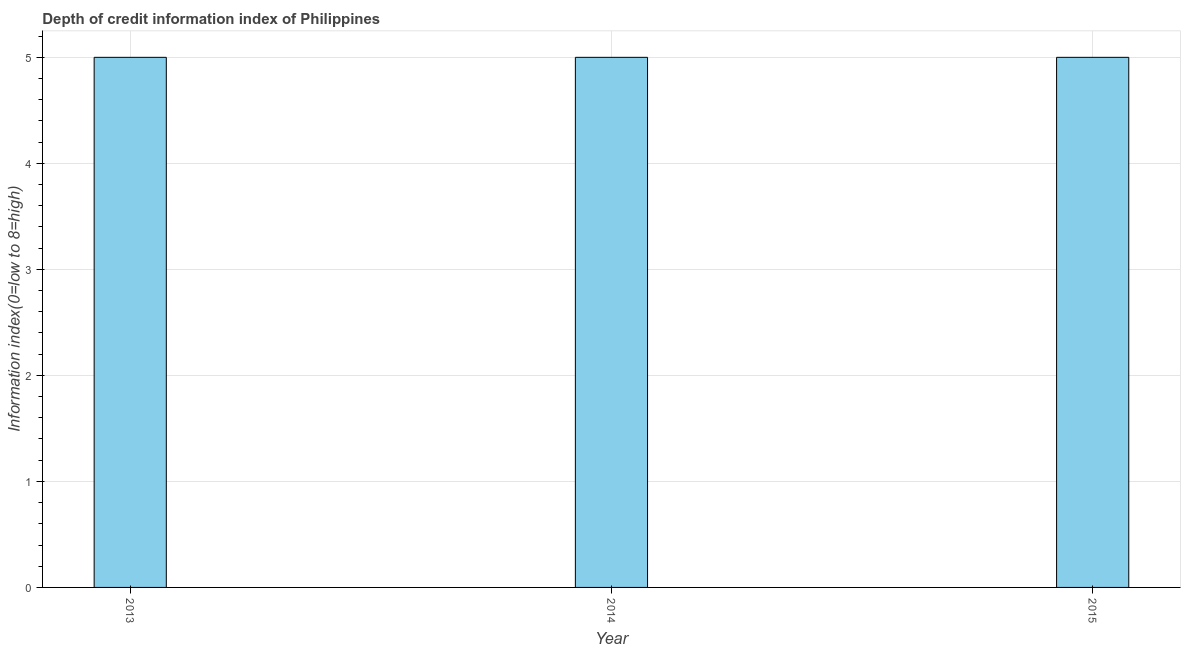What is the title of the graph?
Give a very brief answer. Depth of credit information index of Philippines. What is the label or title of the X-axis?
Offer a terse response. Year. What is the label or title of the Y-axis?
Give a very brief answer. Information index(0=low to 8=high). What is the depth of credit information index in 2015?
Make the answer very short. 5. Across all years, what is the maximum depth of credit information index?
Keep it short and to the point. 5. What is the median depth of credit information index?
Your response must be concise. 5. Do a majority of the years between 2014 and 2013 (inclusive) have depth of credit information index greater than 2 ?
Your response must be concise. No. What is the ratio of the depth of credit information index in 2013 to that in 2014?
Offer a terse response. 1. Is the depth of credit information index in 2014 less than that in 2015?
Provide a succinct answer. No. What is the difference between the highest and the second highest depth of credit information index?
Keep it short and to the point. 0. Is the sum of the depth of credit information index in 2014 and 2015 greater than the maximum depth of credit information index across all years?
Give a very brief answer. Yes. How many bars are there?
Your answer should be very brief. 3. Are all the bars in the graph horizontal?
Provide a short and direct response. No. What is the difference between two consecutive major ticks on the Y-axis?
Provide a succinct answer. 1. Are the values on the major ticks of Y-axis written in scientific E-notation?
Your answer should be compact. No. What is the Information index(0=low to 8=high) in 2015?
Provide a short and direct response. 5. What is the difference between the Information index(0=low to 8=high) in 2013 and 2015?
Your answer should be compact. 0. What is the difference between the Information index(0=low to 8=high) in 2014 and 2015?
Your answer should be very brief. 0. What is the ratio of the Information index(0=low to 8=high) in 2014 to that in 2015?
Provide a short and direct response. 1. 